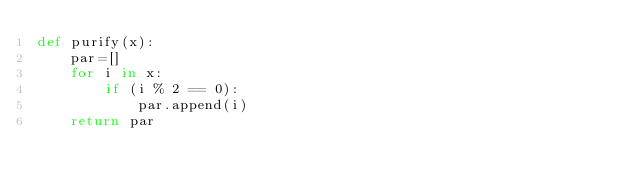Convert code to text. <code><loc_0><loc_0><loc_500><loc_500><_Python_>def purify(x):
    par=[]
    for i in x:
        if (i % 2 == 0):
            par.append(i)
    return par
</code> 